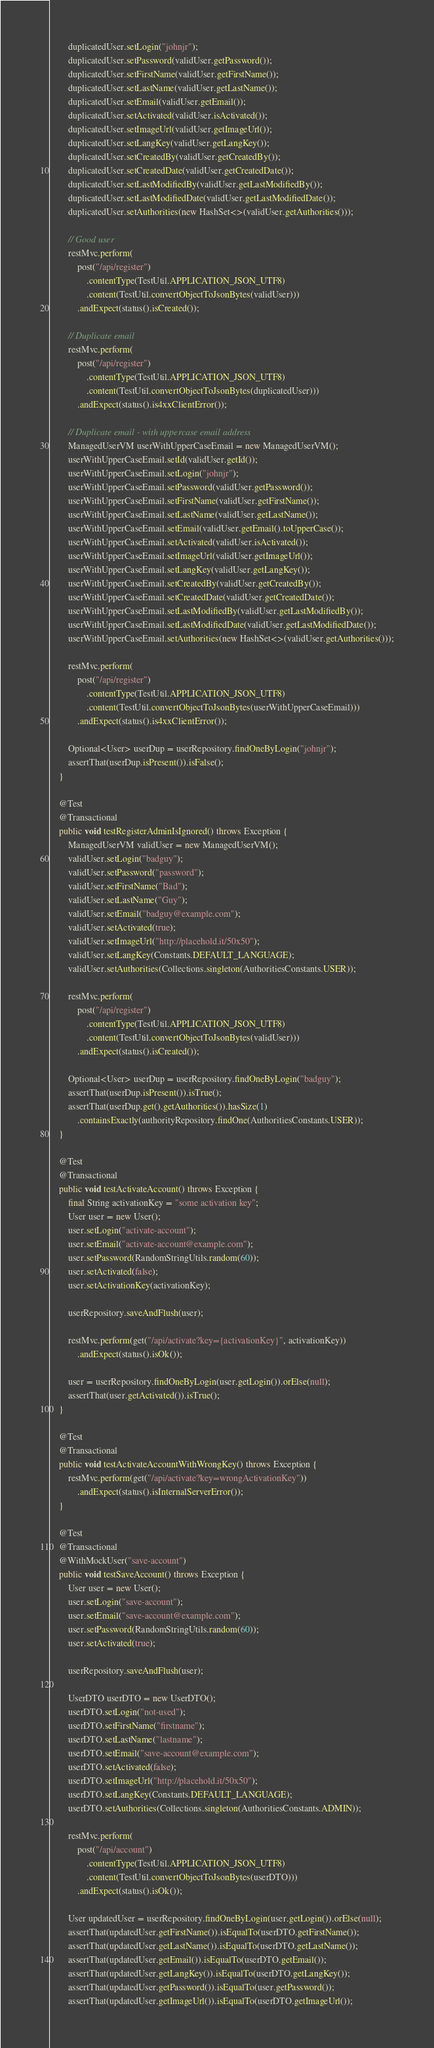Convert code to text. <code><loc_0><loc_0><loc_500><loc_500><_Java_>        duplicatedUser.setLogin("johnjr");
        duplicatedUser.setPassword(validUser.getPassword());
        duplicatedUser.setFirstName(validUser.getFirstName());
        duplicatedUser.setLastName(validUser.getLastName());
        duplicatedUser.setEmail(validUser.getEmail());
        duplicatedUser.setActivated(validUser.isActivated());
        duplicatedUser.setImageUrl(validUser.getImageUrl());
        duplicatedUser.setLangKey(validUser.getLangKey());
        duplicatedUser.setCreatedBy(validUser.getCreatedBy());
        duplicatedUser.setCreatedDate(validUser.getCreatedDate());
        duplicatedUser.setLastModifiedBy(validUser.getLastModifiedBy());
        duplicatedUser.setLastModifiedDate(validUser.getLastModifiedDate());
        duplicatedUser.setAuthorities(new HashSet<>(validUser.getAuthorities()));

        // Good user
        restMvc.perform(
            post("/api/register")
                .contentType(TestUtil.APPLICATION_JSON_UTF8)
                .content(TestUtil.convertObjectToJsonBytes(validUser)))
            .andExpect(status().isCreated());

        // Duplicate email
        restMvc.perform(
            post("/api/register")
                .contentType(TestUtil.APPLICATION_JSON_UTF8)
                .content(TestUtil.convertObjectToJsonBytes(duplicatedUser)))
            .andExpect(status().is4xxClientError());

        // Duplicate email - with uppercase email address
        ManagedUserVM userWithUpperCaseEmail = new ManagedUserVM();
        userWithUpperCaseEmail.setId(validUser.getId());
        userWithUpperCaseEmail.setLogin("johnjr");
        userWithUpperCaseEmail.setPassword(validUser.getPassword());
        userWithUpperCaseEmail.setFirstName(validUser.getFirstName());
        userWithUpperCaseEmail.setLastName(validUser.getLastName());
        userWithUpperCaseEmail.setEmail(validUser.getEmail().toUpperCase());
        userWithUpperCaseEmail.setActivated(validUser.isActivated());
        userWithUpperCaseEmail.setImageUrl(validUser.getImageUrl());
        userWithUpperCaseEmail.setLangKey(validUser.getLangKey());
        userWithUpperCaseEmail.setCreatedBy(validUser.getCreatedBy());
        userWithUpperCaseEmail.setCreatedDate(validUser.getCreatedDate());
        userWithUpperCaseEmail.setLastModifiedBy(validUser.getLastModifiedBy());
        userWithUpperCaseEmail.setLastModifiedDate(validUser.getLastModifiedDate());
        userWithUpperCaseEmail.setAuthorities(new HashSet<>(validUser.getAuthorities()));

        restMvc.perform(
            post("/api/register")
                .contentType(TestUtil.APPLICATION_JSON_UTF8)
                .content(TestUtil.convertObjectToJsonBytes(userWithUpperCaseEmail)))
            .andExpect(status().is4xxClientError());

        Optional<User> userDup = userRepository.findOneByLogin("johnjr");
        assertThat(userDup.isPresent()).isFalse();
    }

    @Test
    @Transactional
    public void testRegisterAdminIsIgnored() throws Exception {
        ManagedUserVM validUser = new ManagedUserVM();
        validUser.setLogin("badguy");
        validUser.setPassword("password");
        validUser.setFirstName("Bad");
        validUser.setLastName("Guy");
        validUser.setEmail("badguy@example.com");
        validUser.setActivated(true);
        validUser.setImageUrl("http://placehold.it/50x50");
        validUser.setLangKey(Constants.DEFAULT_LANGUAGE);
        validUser.setAuthorities(Collections.singleton(AuthoritiesConstants.USER));

        restMvc.perform(
            post("/api/register")
                .contentType(TestUtil.APPLICATION_JSON_UTF8)
                .content(TestUtil.convertObjectToJsonBytes(validUser)))
            .andExpect(status().isCreated());

        Optional<User> userDup = userRepository.findOneByLogin("badguy");
        assertThat(userDup.isPresent()).isTrue();
        assertThat(userDup.get().getAuthorities()).hasSize(1)
            .containsExactly(authorityRepository.findOne(AuthoritiesConstants.USER));
    }

    @Test
    @Transactional
    public void testActivateAccount() throws Exception {
        final String activationKey = "some activation key";
        User user = new User();
        user.setLogin("activate-account");
        user.setEmail("activate-account@example.com");
        user.setPassword(RandomStringUtils.random(60));
        user.setActivated(false);
        user.setActivationKey(activationKey);

        userRepository.saveAndFlush(user);

        restMvc.perform(get("/api/activate?key={activationKey}", activationKey))
            .andExpect(status().isOk());

        user = userRepository.findOneByLogin(user.getLogin()).orElse(null);
        assertThat(user.getActivated()).isTrue();
    }

    @Test
    @Transactional
    public void testActivateAccountWithWrongKey() throws Exception {
        restMvc.perform(get("/api/activate?key=wrongActivationKey"))
            .andExpect(status().isInternalServerError());
    }

    @Test
    @Transactional
    @WithMockUser("save-account")
    public void testSaveAccount() throws Exception {
        User user = new User();
        user.setLogin("save-account");
        user.setEmail("save-account@example.com");
        user.setPassword(RandomStringUtils.random(60));
        user.setActivated(true);

        userRepository.saveAndFlush(user);

        UserDTO userDTO = new UserDTO();
        userDTO.setLogin("not-used");
        userDTO.setFirstName("firstname");
        userDTO.setLastName("lastname");
        userDTO.setEmail("save-account@example.com");
        userDTO.setActivated(false);
        userDTO.setImageUrl("http://placehold.it/50x50");
        userDTO.setLangKey(Constants.DEFAULT_LANGUAGE);
        userDTO.setAuthorities(Collections.singleton(AuthoritiesConstants.ADMIN));

        restMvc.perform(
            post("/api/account")
                .contentType(TestUtil.APPLICATION_JSON_UTF8)
                .content(TestUtil.convertObjectToJsonBytes(userDTO)))
            .andExpect(status().isOk());

        User updatedUser = userRepository.findOneByLogin(user.getLogin()).orElse(null);
        assertThat(updatedUser.getFirstName()).isEqualTo(userDTO.getFirstName());
        assertThat(updatedUser.getLastName()).isEqualTo(userDTO.getLastName());
        assertThat(updatedUser.getEmail()).isEqualTo(userDTO.getEmail());
        assertThat(updatedUser.getLangKey()).isEqualTo(userDTO.getLangKey());
        assertThat(updatedUser.getPassword()).isEqualTo(user.getPassword());
        assertThat(updatedUser.getImageUrl()).isEqualTo(userDTO.getImageUrl());</code> 